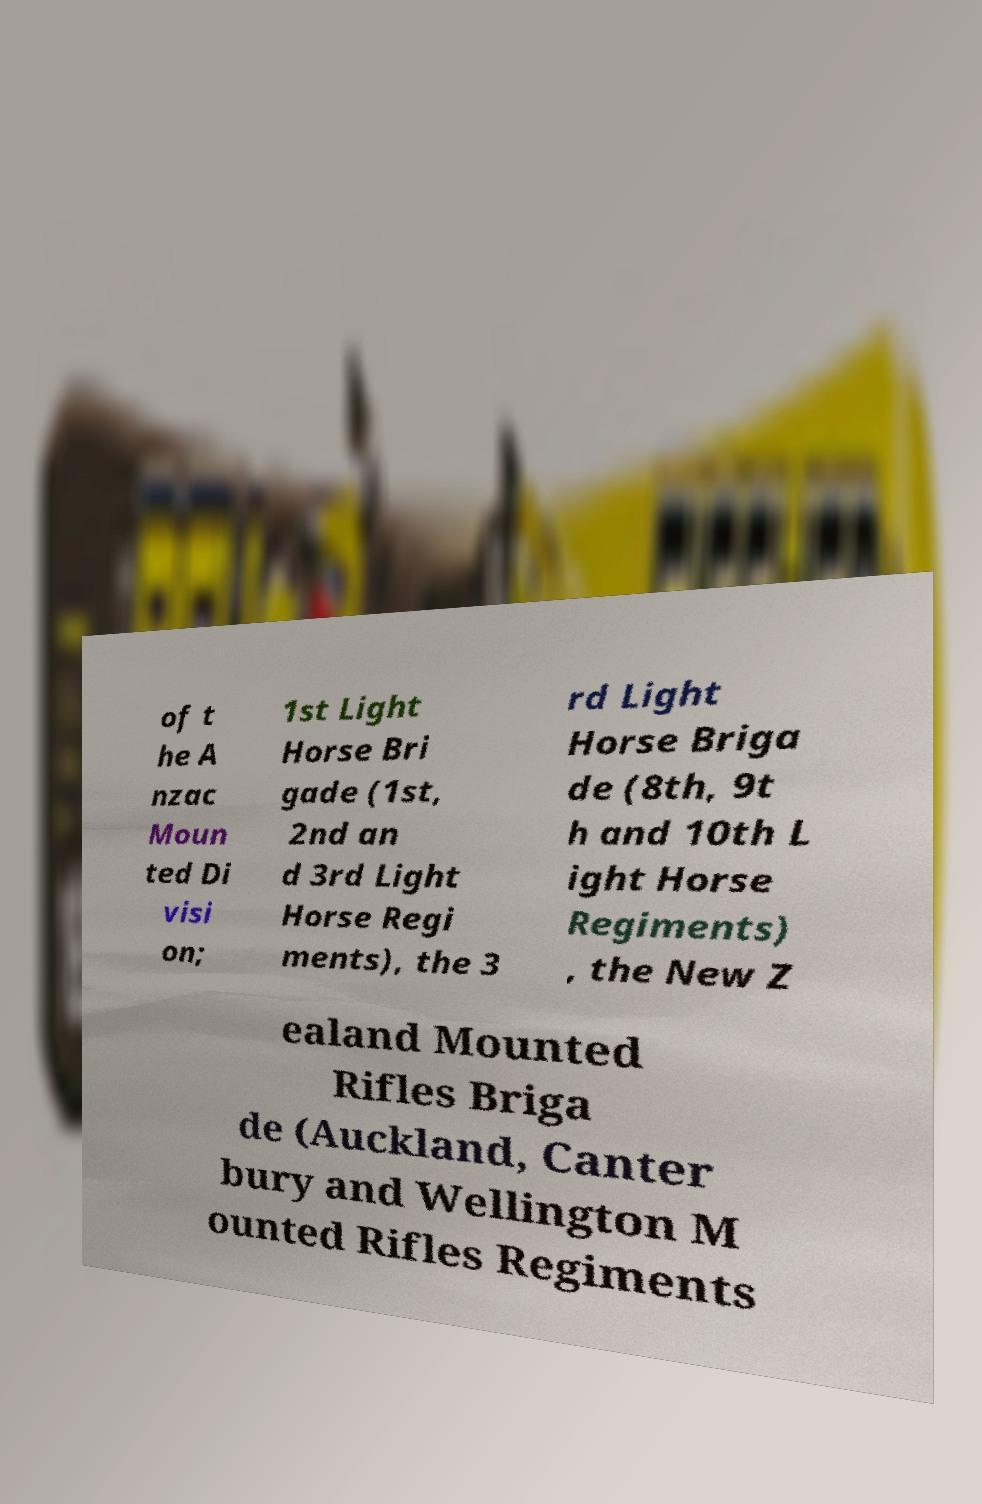Can you read and provide the text displayed in the image?This photo seems to have some interesting text. Can you extract and type it out for me? of t he A nzac Moun ted Di visi on; 1st Light Horse Bri gade (1st, 2nd an d 3rd Light Horse Regi ments), the 3 rd Light Horse Briga de (8th, 9t h and 10th L ight Horse Regiments) , the New Z ealand Mounted Rifles Briga de (Auckland, Canter bury and Wellington M ounted Rifles Regiments 